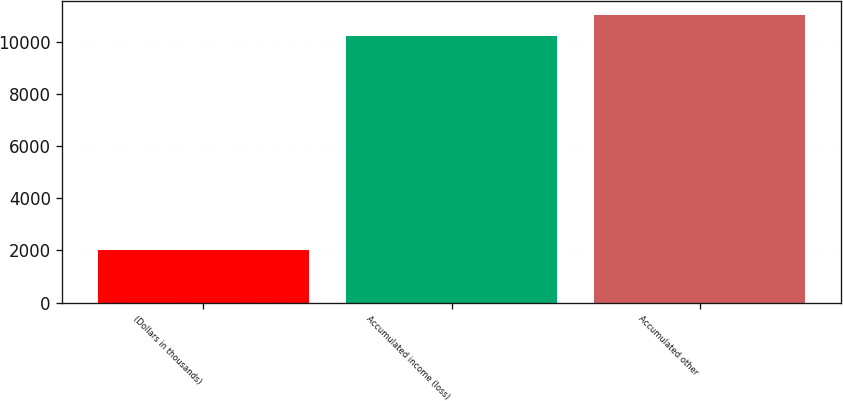Convert chart to OTSL. <chart><loc_0><loc_0><loc_500><loc_500><bar_chart><fcel>(Dollars in thousands)<fcel>Accumulated income (loss)<fcel>Accumulated other<nl><fcel>2012<fcel>10231<fcel>11052.9<nl></chart> 